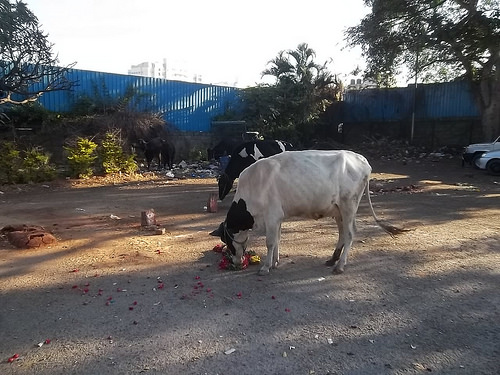<image>
Is the car behind the cow? Yes. From this viewpoint, the car is positioned behind the cow, with the cow partially or fully occluding the car. 